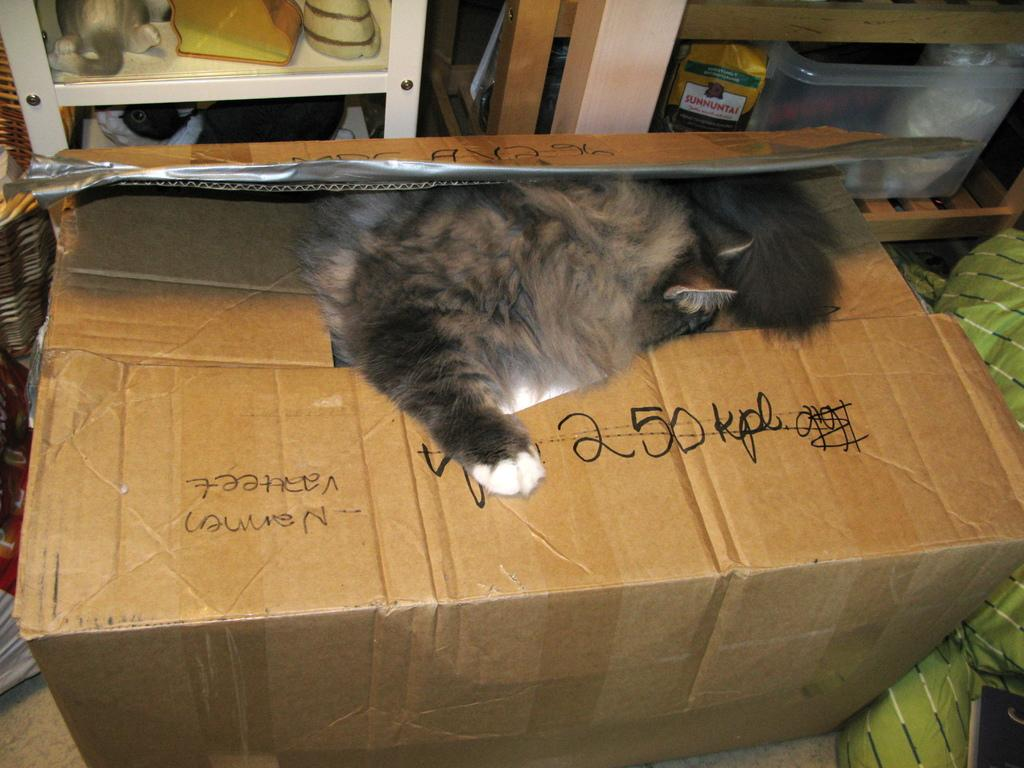<image>
Describe the image concisely. A cat laying on top of a box with 250 kpl written in sharpie on top. 